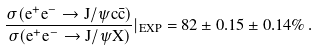Convert formula to latex. <formula><loc_0><loc_0><loc_500><loc_500>\frac { \sigma ( e ^ { + } e ^ { - } \rightarrow J / \psi c \bar { c } ) } { \sigma ( e ^ { + } e ^ { - } \rightarrow J / \psi X ) } | _ { E X P } = 8 2 \pm 0 . 1 5 \pm 0 . 1 4 \% \, .</formula> 